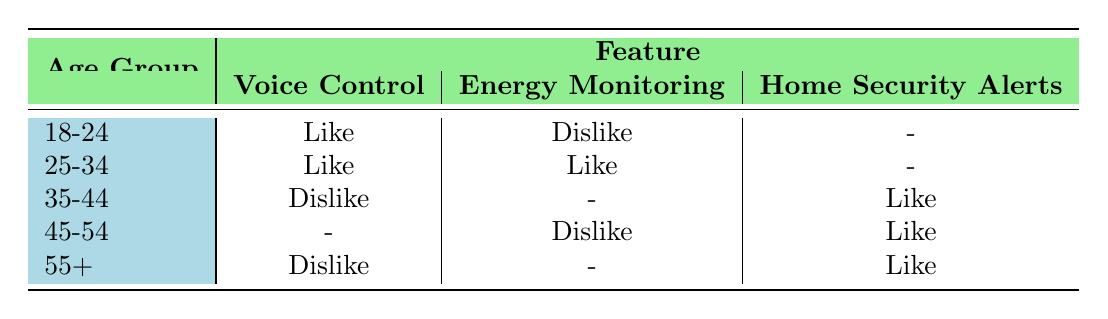What is the preference of the 25-34 age group for Voice Control? According to the table, the preference for Voice Control in the 25-34 age group is "Like".
Answer: Like Which age group dislikes Energy Monitoring? In the table, the only age group that states a preference of "Dislike" for Energy Monitoring is the 45-54 age group.
Answer: 45-54 How many age groups like Home Security Alerts? The age groups that like Home Security Alerts, as seen in the table, are 35-44, 45-54, and 55+, totaling three age groups.
Answer: 3 Is there any age group that dislikes Voice Control? Based on the table, the age groups 35-44 and 55+ both express a preference of "Dislike" for Voice Control, meaning the statement is true.
Answer: Yes What is the total number of age groups represented in the table? The table lists five distinct age groups: 18-24, 25-34, 35-44, 45-54, and 55+. Therefore, the total count of age groups is five.
Answer: 5 Which age group has the highest diversity in feature preferences? The age group 25-34 shows preferences for both Voice Control and Energy Monitoring as "Like", but there is no preference listed under Home Security Alerts. The diversity can't be determined solely from liking and disliking multiple features like other age groups show; thus it might be more challenging to assess. This group has one "Like" for each of two features, but with a missing entry. Therefore, it may be likely that 35-44, with a "Like" for Home Security Alerts and a "Dislike" for Voice Control is broader in expressing varying views, though we cannot pinpoint a definite preference diversity measure from the table.
Answer: 25-34, predominantly liking both Voice Control and Energy Monitoring What would be the outcome if the preferences for Energy Monitoring were to be averaged across the age groups? "Like" appears in the 25-34 age group, while "Dislike" appears in 18-24 and 45-54 age groups while the 35-44 and 55+ groups do not respond. To average overall sentiment, one would find a balance of preferences. 3 total indications (2 for like and 2 for dislike) could lead to a neutral opinion. However, because there are no quantifiable measures in "like" versus "dislike" without an appropriate value assigned, averaging leads to a neutral, unclear position where preference is neither confirmed nor negated clearly. Thus without a value set, averaging cannot be calculated.
Answer: Cannot determine an average How many users expressed a "Dislike" for Home Security Alerts? The data shows that only the 35-44 age group expresses a liking for Home Security Alerts, while all others have their respective likes and no disliking were listed so, effectively no users express a dislike. Therefore, the total is zero.
Answer: 0 